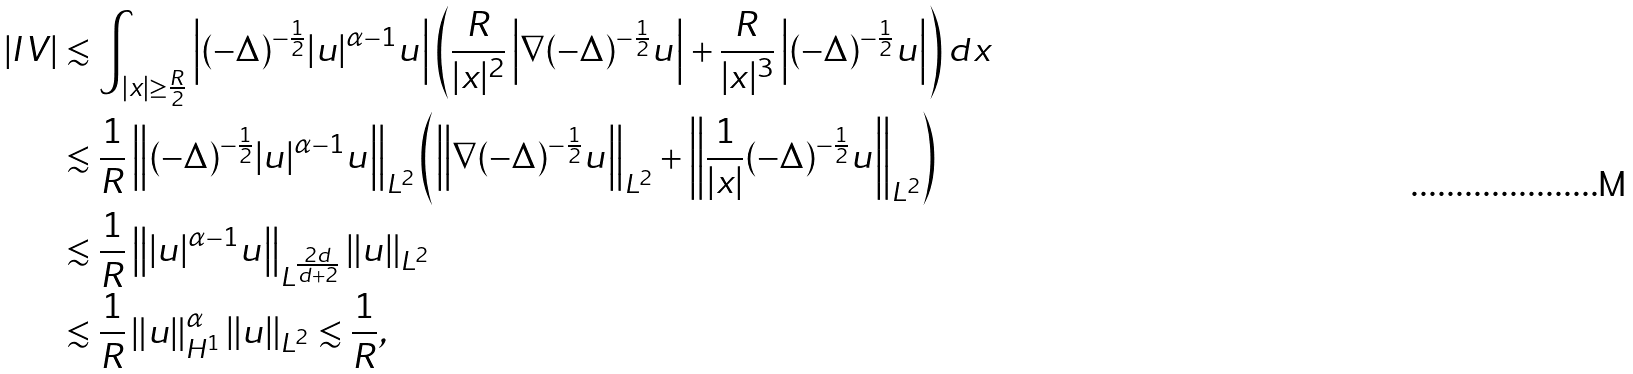Convert formula to latex. <formula><loc_0><loc_0><loc_500><loc_500>\left | I V \right | & \lesssim \int _ { | x | \geq \frac { R } { 2 } } \left | ( - \Delta ) ^ { - \frac { 1 } { 2 } } | u | ^ { \alpha - 1 } u \right | \left ( \frac { R } { | x | ^ { 2 } } \left | \nabla ( - \Delta ) ^ { - \frac { 1 } { 2 } } u \right | + \frac { R } { | x | ^ { 3 } } \left | ( - \Delta ) ^ { - \frac { 1 } { 2 } } u \right | \right ) d x \\ & \lesssim \frac { 1 } { R } \left \| ( - \Delta ) ^ { - \frac { 1 } { 2 } } | u | ^ { \alpha - 1 } u \right \| _ { L ^ { 2 } } \left ( \left \| \nabla ( - \Delta ) ^ { - \frac { 1 } { 2 } } u \right \| _ { L ^ { 2 } } + \left \| \frac { 1 } { | x | } ( - \Delta ) ^ { - \frac { 1 } { 2 } } u \right \| _ { L ^ { 2 } } \right ) \\ & \lesssim \frac { 1 } { R } \left \| | u | ^ { \alpha - 1 } u \right \| _ { L ^ { \frac { 2 d } { d + 2 } } } \| u \| _ { L ^ { 2 } } \\ & \lesssim \frac { 1 } { R } \left \| u \right \| ^ { \alpha } _ { H ^ { 1 } } \| u \| _ { L ^ { 2 } } \lesssim \frac { 1 } { R } ,</formula> 